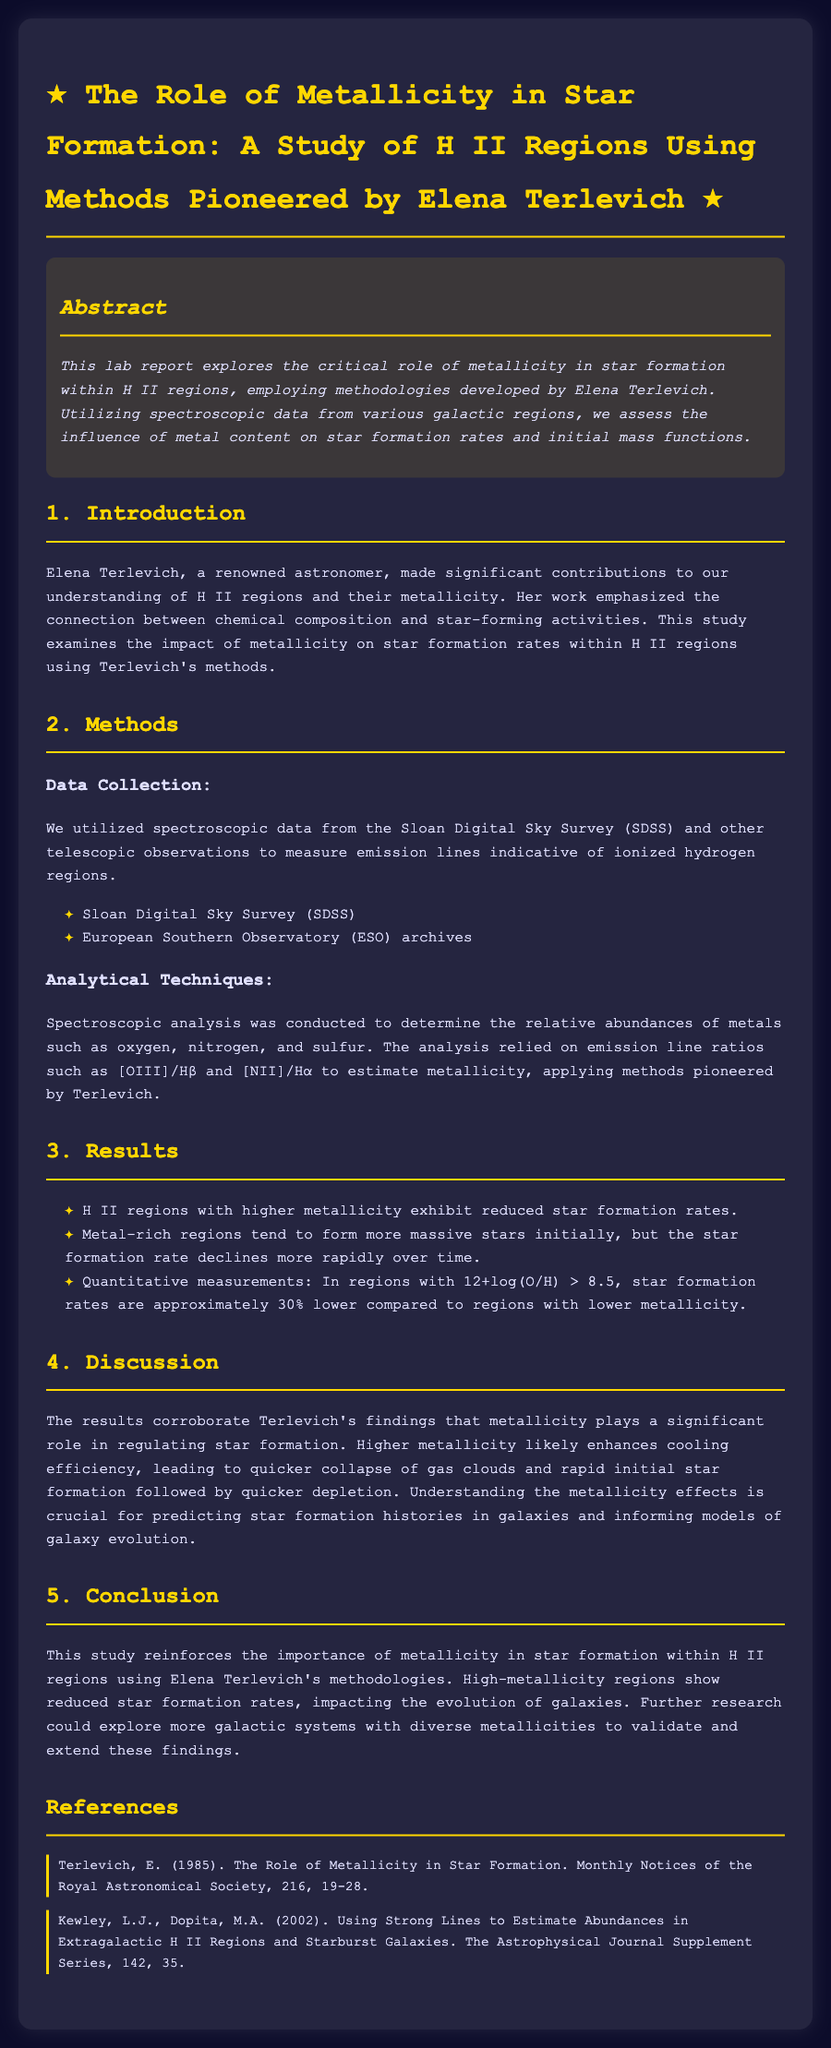What is the title of the lab report? The title of the lab report is found at the top of the document.
Answer: The Role of Metallicity in Star Formation: A Study of H II Regions Using Methods Pioneered by Elena Terlevich Who pioneered the methods used in the study? The document states that the methodologies used in the study were developed by a specific astronomer.
Answer: Elena Terlevich What are the two main sources of data mentioned in the Methods section? The document lists specific sources used for spectroscopic data collection.
Answer: Sloan Digital Sky Survey (SDSS) and European Southern Observatory (ESO) archives How much lower are star formation rates in regions with high metallicity compared to lower metallicity regions? The document quantitatively describes the difference in star formation rates based on metallicity.
Answer: Approximately 30% lower What is the main finding in relation to higher metallicity and star formation? The discussion section summarizes the findings related to metallicity and its effect on star formation rates.
Answer: Higher metallicity leads to reduced star formation rates What is the key conclusion drawn from the study? The conclusion summarizes the impact of metallicity on star formation within H II regions.
Answer: The importance of metallicity in star formation Which journal published Terlevich's significant work in 1985? The references section provides the title and journal name where Terlevich's work was published.
Answer: Monthly Notices of the Royal Astronomical Society 